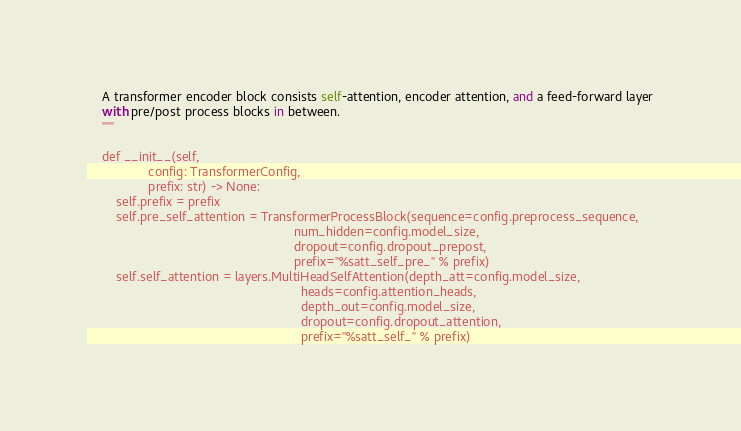Convert code to text. <code><loc_0><loc_0><loc_500><loc_500><_Python_>    A transformer encoder block consists self-attention, encoder attention, and a feed-forward layer
    with pre/post process blocks in between.
    """

    def __init__(self,
                 config: TransformerConfig,
                 prefix: str) -> None:
        self.prefix = prefix
        self.pre_self_attention = TransformerProcessBlock(sequence=config.preprocess_sequence,
                                                          num_hidden=config.model_size,
                                                          dropout=config.dropout_prepost,
                                                          prefix="%satt_self_pre_" % prefix)
        self.self_attention = layers.MultiHeadSelfAttention(depth_att=config.model_size,
                                                            heads=config.attention_heads,
                                                            depth_out=config.model_size,
                                                            dropout=config.dropout_attention,
                                                            prefix="%satt_self_" % prefix)</code> 